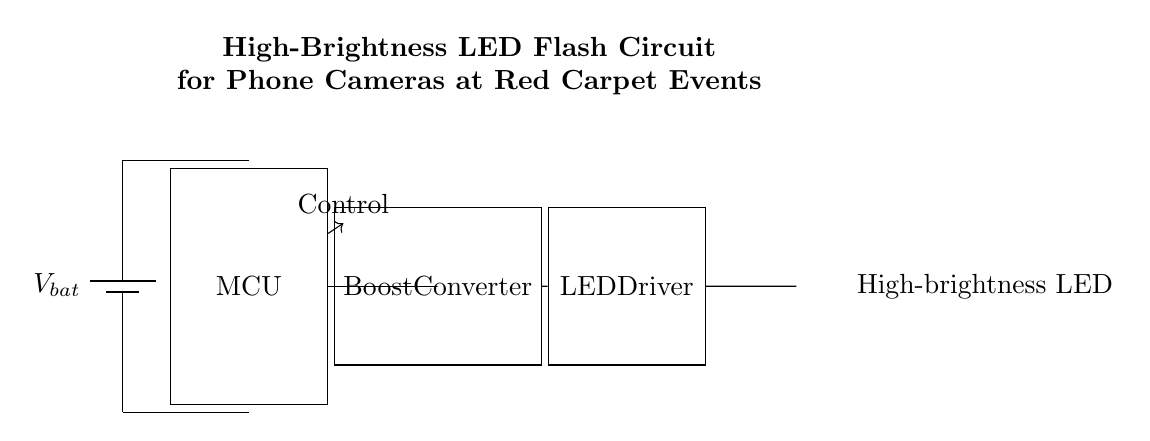What is the power source in this circuit? The power source in this circuit is represented by the battery symbol, labeled as V bat.
Answer: V bat What component controls the LED flash? The component that controls the LED flash is the microcontroller, indicated as MCU in the circuit diagram.
Answer: MCU What is the purpose of the boost converter? The boost converter increases the voltage to meet the high requirements of the LED driver from the battery voltage.
Answer: Increase voltage What kind of LED is used in this circuit? The LED used in this circuit is a high-brightness LED, specifically marked in red in the diagram.
Answer: High-brightness LED What signal does the microcontroller send to the rest of the circuit? The microcontroller sends a control signal to manage the operation of the boost converter and LED driver.
Answer: Control signal How many main components are visible in the circuit? There are four main components visible in the circuit: the battery, microcontroller, boost converter, and LED driver.
Answer: Four components What color is the LED in the circuit? The LED in the circuit diagram is red, as denoted by the color depiction in the LED symbol.
Answer: Red 